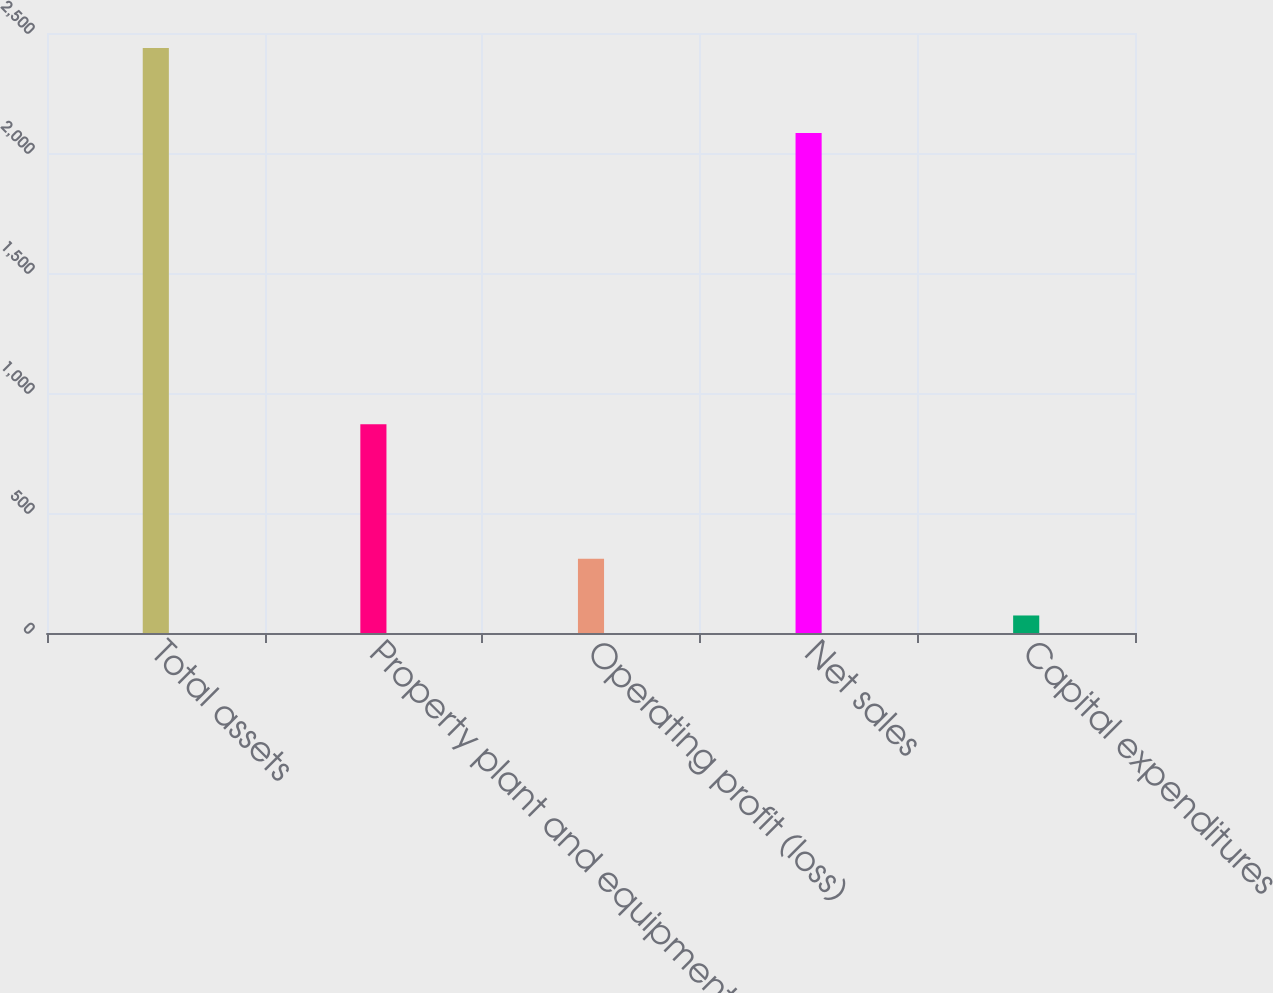Convert chart. <chart><loc_0><loc_0><loc_500><loc_500><bar_chart><fcel>Total assets<fcel>Property plant and equipment<fcel>Operating profit (loss)<fcel>Net sales<fcel>Capital expenditures<nl><fcel>2437<fcel>870<fcel>309.4<fcel>2083<fcel>73<nl></chart> 